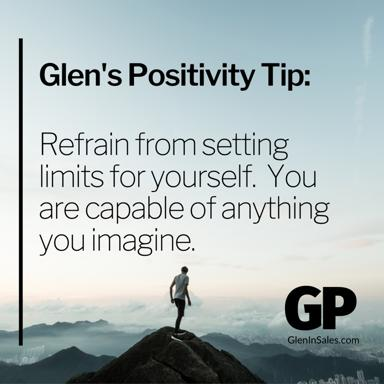What is Glen's Positivity Tip? Glen's Positivity Tip, as depicted in the image, advocates for the bold idea of not setting self-imposed limitations. It highlights that what we can achieve is boundless if we allow ourselves to think and dream without constraints. This tip, illustrated by a figure standing triumphantly atop a mountain, serves as a powerful metaphor for reaching new heights in personal development and achievements when we expand our mental boundaries. 